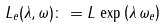Convert formula to latex. <formula><loc_0><loc_0><loc_500><loc_500>L _ { e } ( \lambda , \omega ) \colon = L \, \exp \left ( \lambda \, \omega _ { e } \right )</formula> 